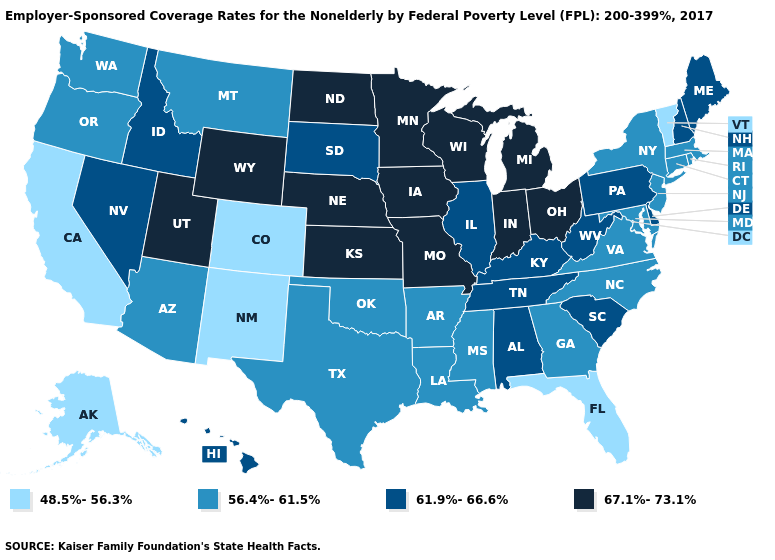Name the states that have a value in the range 56.4%-61.5%?
Give a very brief answer. Arizona, Arkansas, Connecticut, Georgia, Louisiana, Maryland, Massachusetts, Mississippi, Montana, New Jersey, New York, North Carolina, Oklahoma, Oregon, Rhode Island, Texas, Virginia, Washington. What is the highest value in states that border Texas?
Answer briefly. 56.4%-61.5%. Which states have the lowest value in the USA?
Write a very short answer. Alaska, California, Colorado, Florida, New Mexico, Vermont. Among the states that border Oklahoma , does New Mexico have the lowest value?
Quick response, please. Yes. Name the states that have a value in the range 56.4%-61.5%?
Concise answer only. Arizona, Arkansas, Connecticut, Georgia, Louisiana, Maryland, Massachusetts, Mississippi, Montana, New Jersey, New York, North Carolina, Oklahoma, Oregon, Rhode Island, Texas, Virginia, Washington. Which states have the lowest value in the South?
Write a very short answer. Florida. Which states have the lowest value in the MidWest?
Concise answer only. Illinois, South Dakota. Among the states that border Wyoming , does South Dakota have the lowest value?
Give a very brief answer. No. What is the value of Kansas?
Quick response, please. 67.1%-73.1%. What is the value of Montana?
Short answer required. 56.4%-61.5%. What is the value of Rhode Island?
Keep it brief. 56.4%-61.5%. What is the value of Arizona?
Quick response, please. 56.4%-61.5%. What is the value of Connecticut?
Keep it brief. 56.4%-61.5%. What is the highest value in the Northeast ?
Be succinct. 61.9%-66.6%. Name the states that have a value in the range 67.1%-73.1%?
Short answer required. Indiana, Iowa, Kansas, Michigan, Minnesota, Missouri, Nebraska, North Dakota, Ohio, Utah, Wisconsin, Wyoming. 